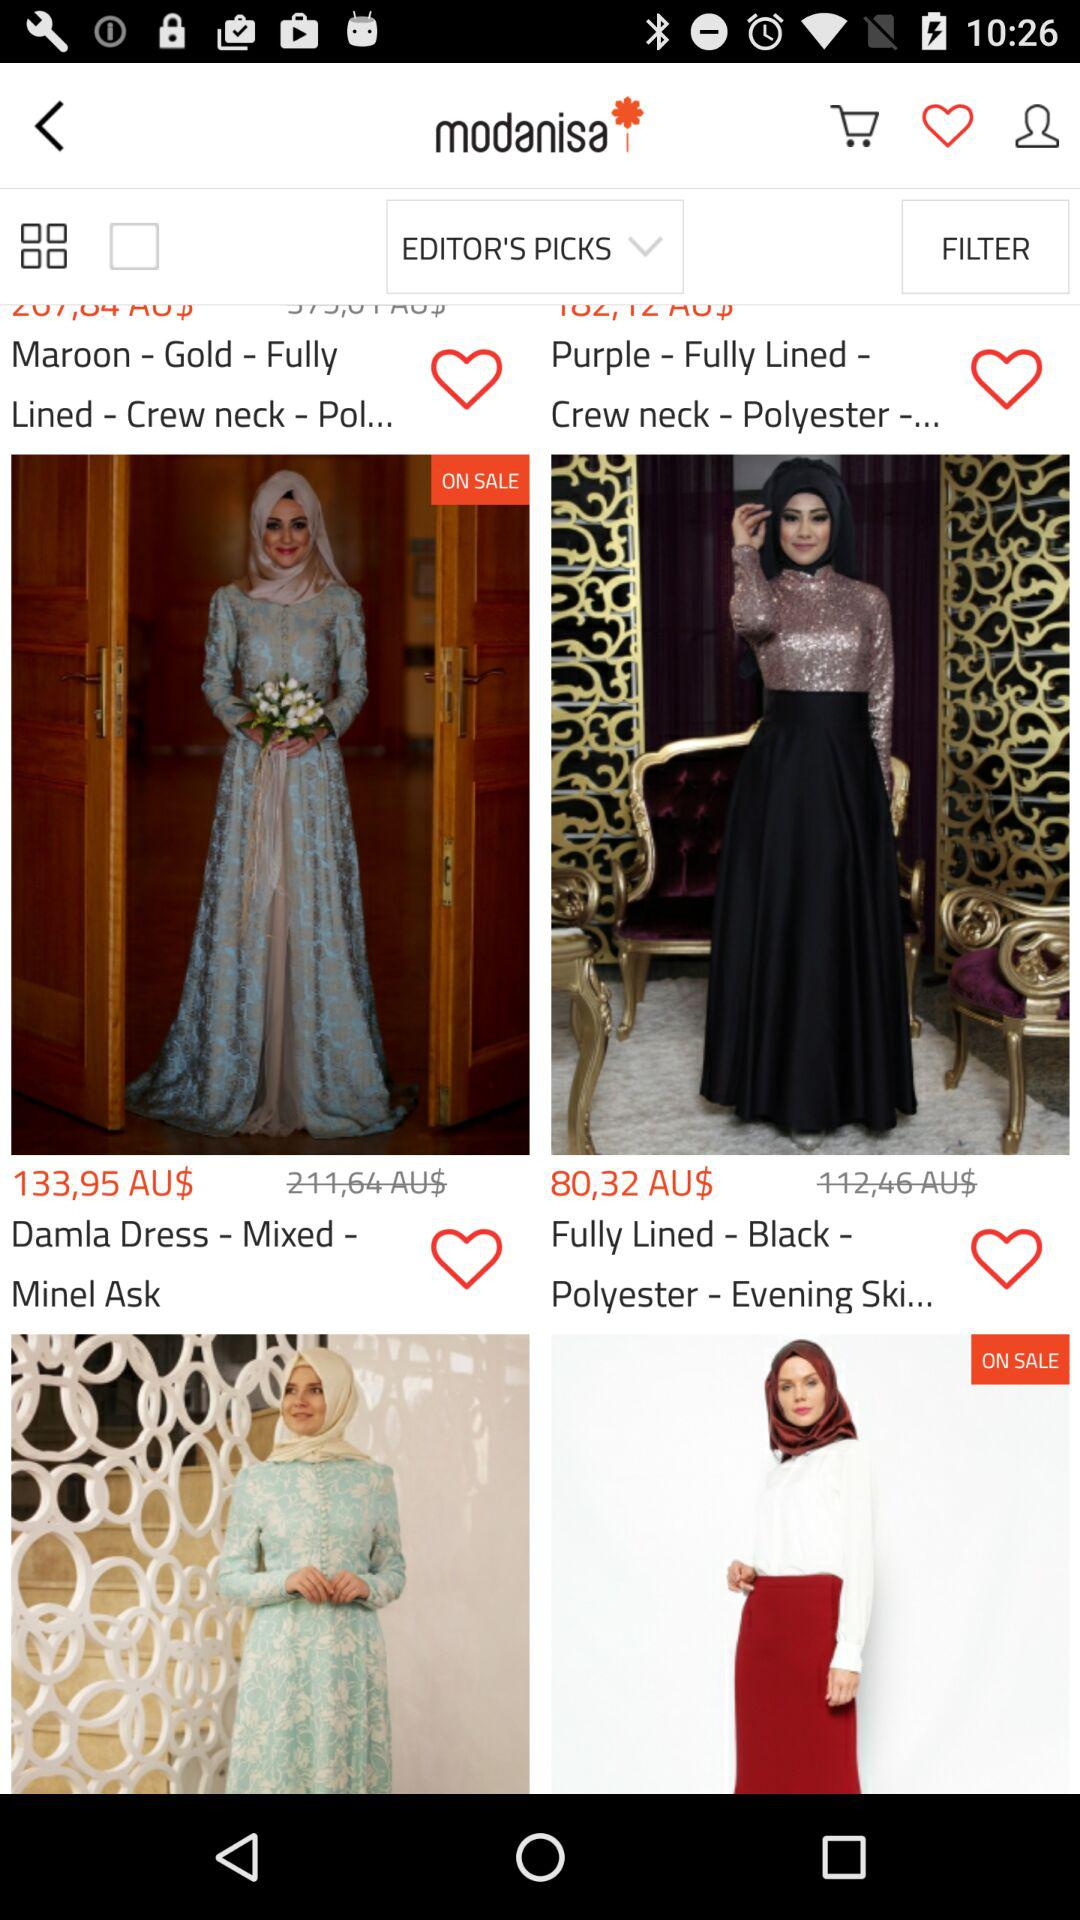How many items are in the user's favorites?
When the provided information is insufficient, respond with <no answer>. <no answer> 